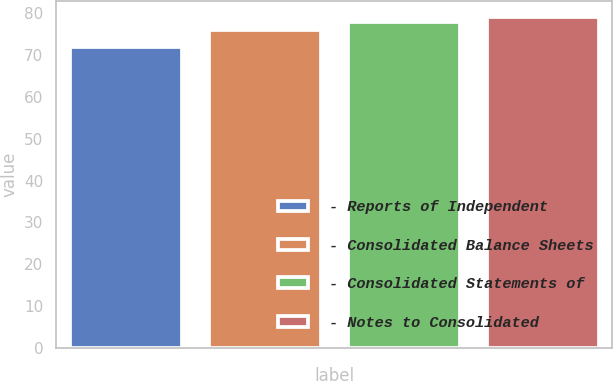Convert chart. <chart><loc_0><loc_0><loc_500><loc_500><bar_chart><fcel>- Reports of Independent<fcel>- Consolidated Balance Sheets<fcel>- Consolidated Statements of<fcel>- Notes to Consolidated<nl><fcel>72<fcel>76<fcel>78<fcel>79<nl></chart> 